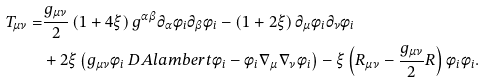<formula> <loc_0><loc_0><loc_500><loc_500>T _ { \mu \nu } = & \frac { g _ { \mu \nu } } { 2 } \left ( 1 + 4 \xi \right ) g ^ { \alpha \beta } \partial _ { \alpha } \phi _ { i } \partial _ { \beta } \phi _ { i } - \left ( 1 + 2 \xi \right ) \partial _ { \mu } \phi _ { i } \partial _ { \nu } \phi _ { i } \\ & + 2 \xi \left ( g _ { \mu \nu } \phi _ { i } \ D A l a m b e r t \phi _ { i } - \phi _ { i } \nabla _ { \mu } \nabla _ { \nu } \phi _ { i } \right ) - \xi \left ( R _ { \mu \nu } - \frac { g _ { \mu \nu } } { 2 } R \right ) \phi _ { i } \phi _ { i } .</formula> 